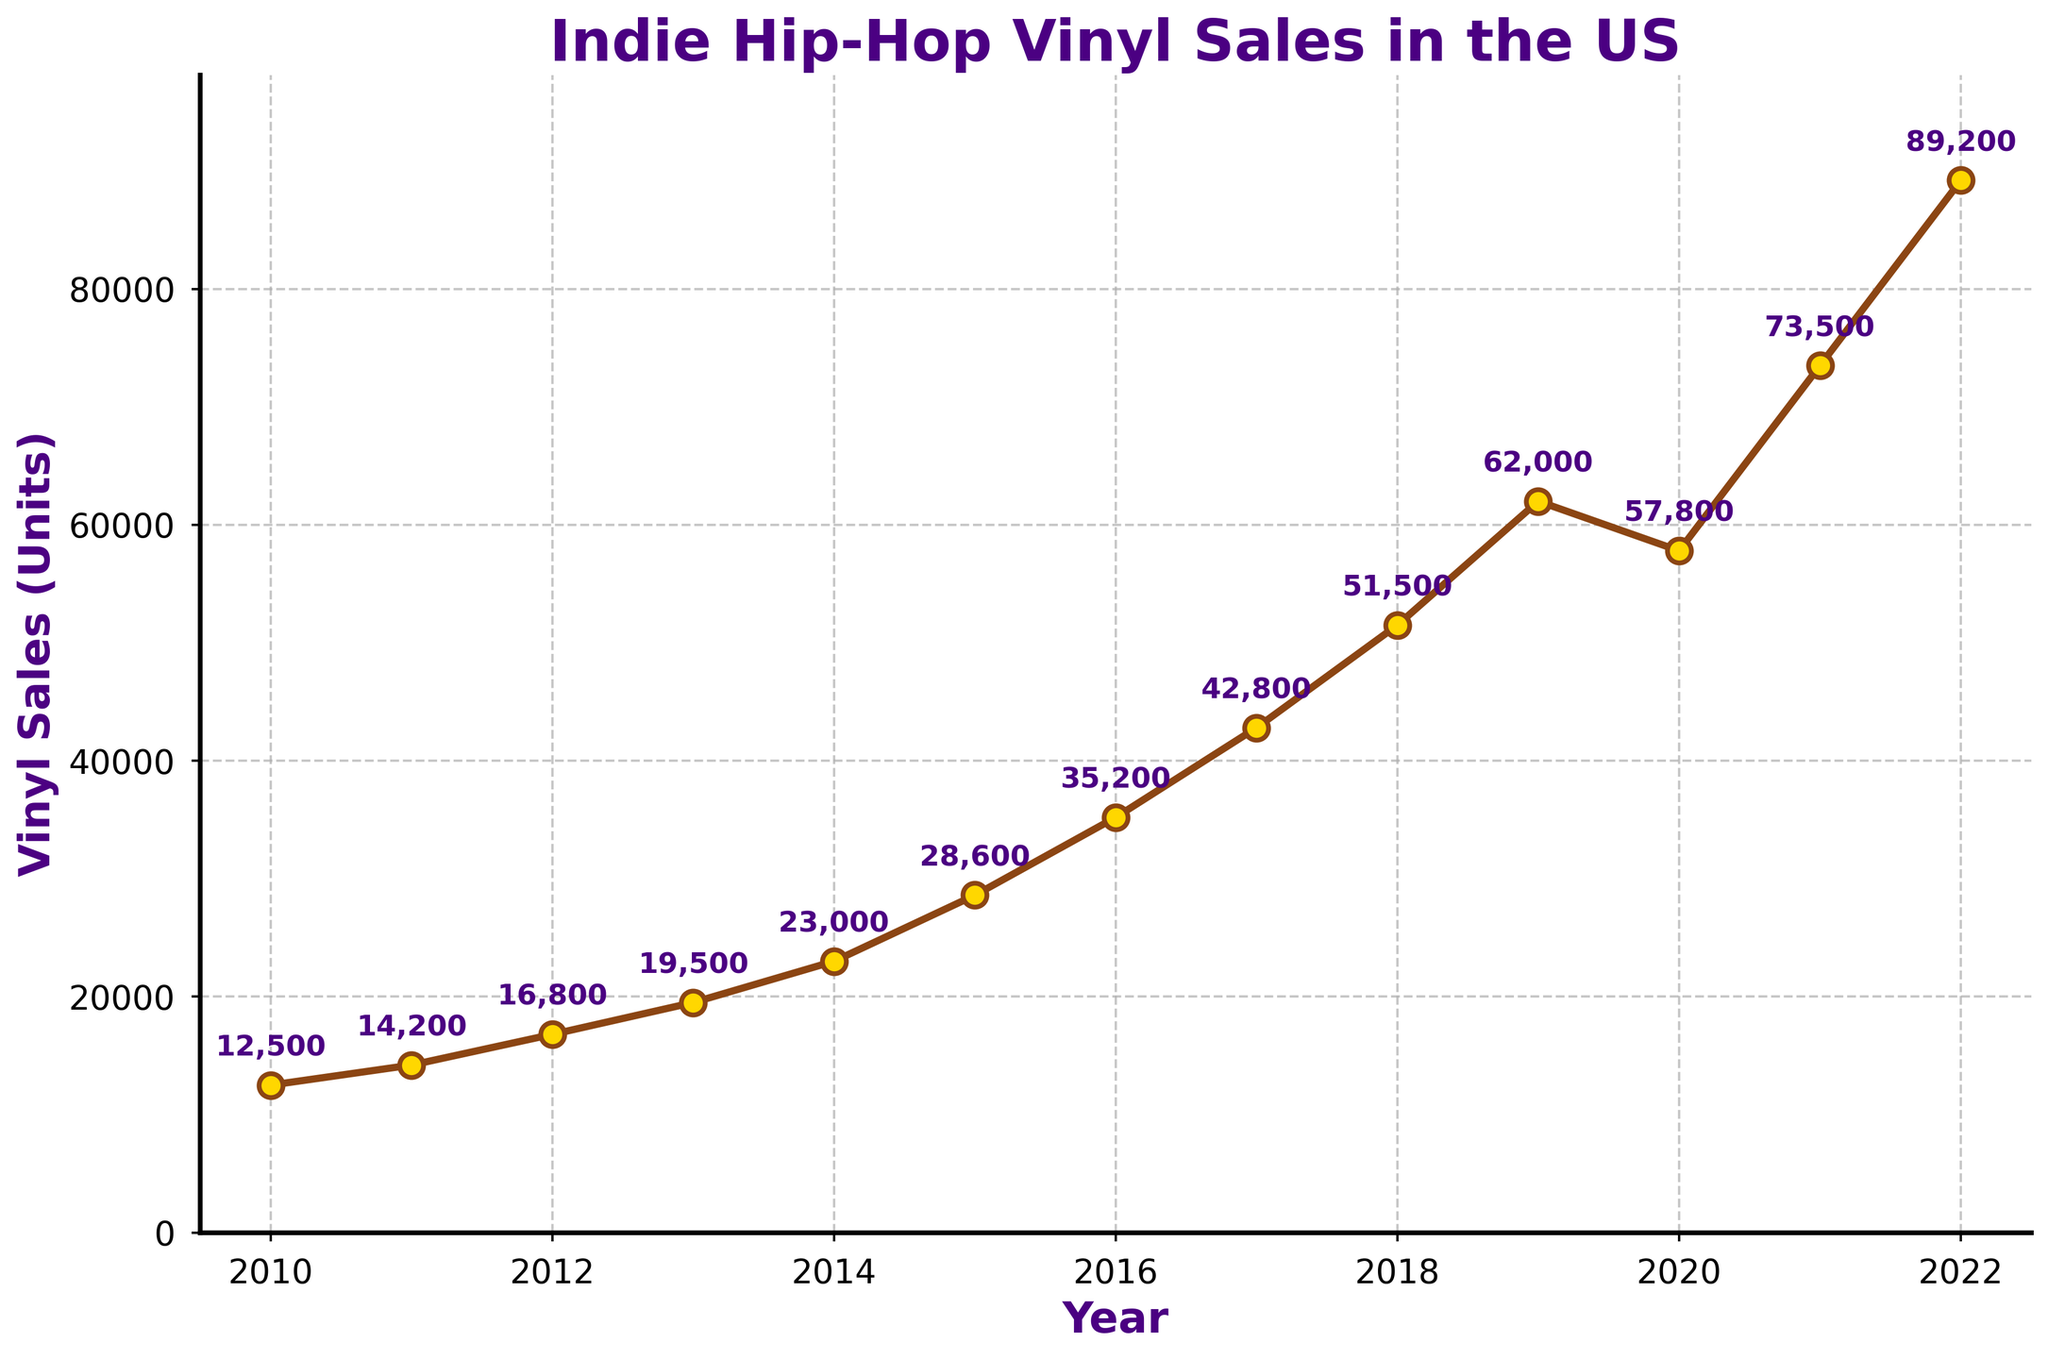What is the general trend of vinyl sales from 2010 to 2022? To determine the general trend, observe the overall direction of the line on the graph. From 2010 to 2022, the line representing vinyl sales is steadily increasing, with only a slight dip in 2020.
Answer: Increasing trend Which year had the highest vinyl sales? The highest point on the line represents the year with the highest sales. The annotation at the topmost point indicates the year 2022 with sales of 89,200 units.
Answer: 2022 Which year experienced the largest increase in vinyl sales compared to the previous year? Compare the difference in sales between consecutive years and find the largest gap. The biggest increase is from 2021 to 2022, where sales jumped from 73,500 to 89,200 units. The increase is 15,700 units.
Answer: 2021 to 2022 What was the lowest point of vinyl sales within the period? Identify the lowest point on the line graph. The lowest sales occurred in 2010, with 12,500 units sold.
Answer: 2010 How did vinyl sales change from 2019 to 2020? Examine the segments of the line for 2019 and 2020. Sales decreased from 62,000 units in 2019 to 57,800 units in 2020, showing a decline.
Answer: Decreased Compare the vinyl sales in 2015 and 2016. Which year had higher sales and by how much? Locate the points for 2015 and 2016 and subtract the value of 2015 from 2016. 2016 had 35,200 units, and 2015 had 28,600 units. The difference is 35,200 - 28,600 = 6,600 units.
Answer: 2016 by 6,600 units What is the average vinyl sales over the years 2010 to 2022? Sum up the sales for each year and divide by the number of years, which is 13. Average = (12500 + 14200 + 16800 + 19500 + 23000 + 28600 + 35200 + 42800 + 51500 + 62000 + 57800 + 73500 + 89200) / 13 = 40,431 units.
Answer: 40,431 units Which year had the smallest increase in vinyl sales compared to the previous year? Compare the differences between consecutive years and identify the smallest. The smallest increase is from 2019 to 2020, with a decrease of 4,200 units, which is the only negative change in the period.
Answer: 2019 to 2020 How many units were sold in total from 2018 to 2022? Sum the sales from each year within this range: 2018 (51,500) + 2019 (62,000) + 2020 (57,800) + 2021 (73,500) + 2022 (89,200) = 334,000 units.
Answer: 334,000 units What is the median vinyl sales between 2010 and 2022? The median is the middle value when the sales figures are sorted in ascending order. The sorted sales: [12,500, 14,200, 16,800, 19,500, 23,000, 28,600, 35,200, 42,800, 51,500, 57,800, 62,000, 73,500, 89,200]. Median is the 7th value, which is 35,200 units.
Answer: 35,200 units 